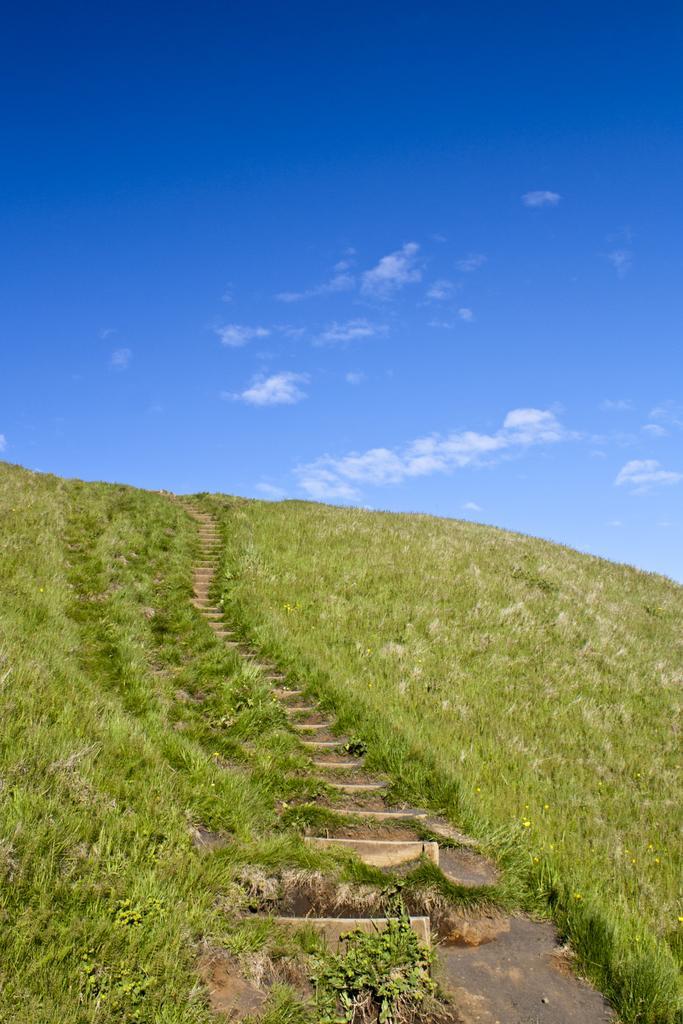How would you summarize this image in a sentence or two? In this image I can see grass, stairs, clouds and the sky in background. 